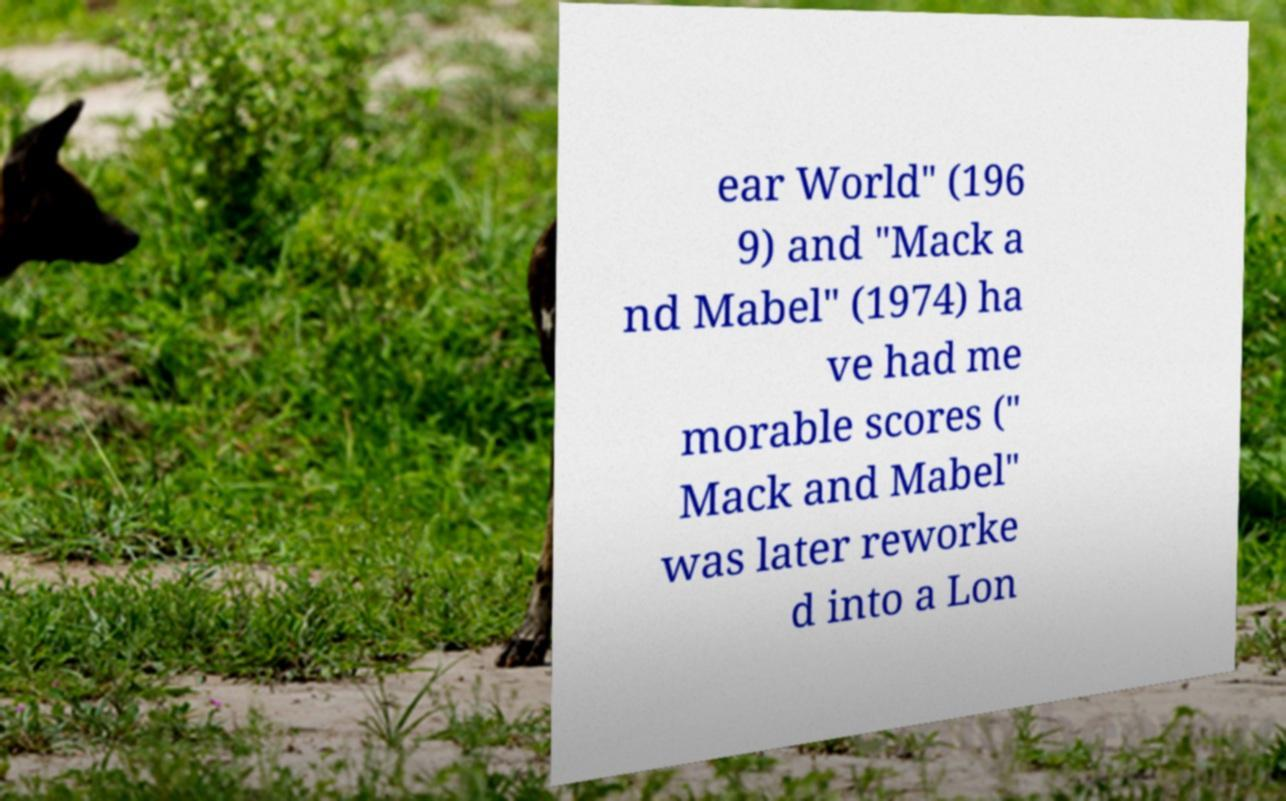What messages or text are displayed in this image? I need them in a readable, typed format. ear World" (196 9) and "Mack a nd Mabel" (1974) ha ve had me morable scores (" Mack and Mabel" was later reworke d into a Lon 